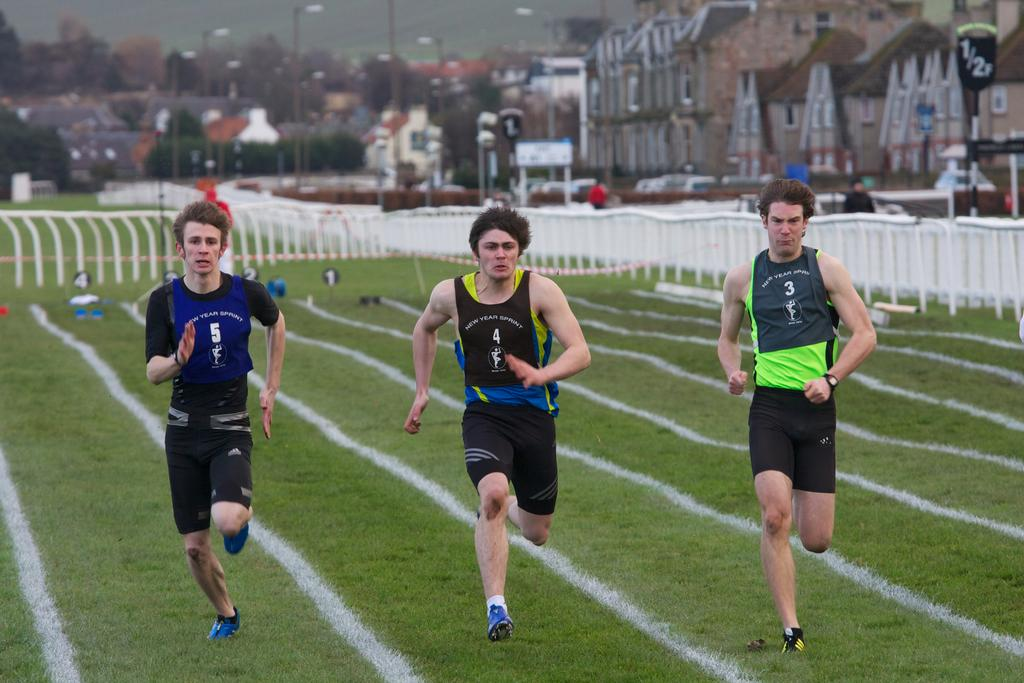<image>
Summarize the visual content of the image. Runners participate in a New Year Sprint on a cloudy day 